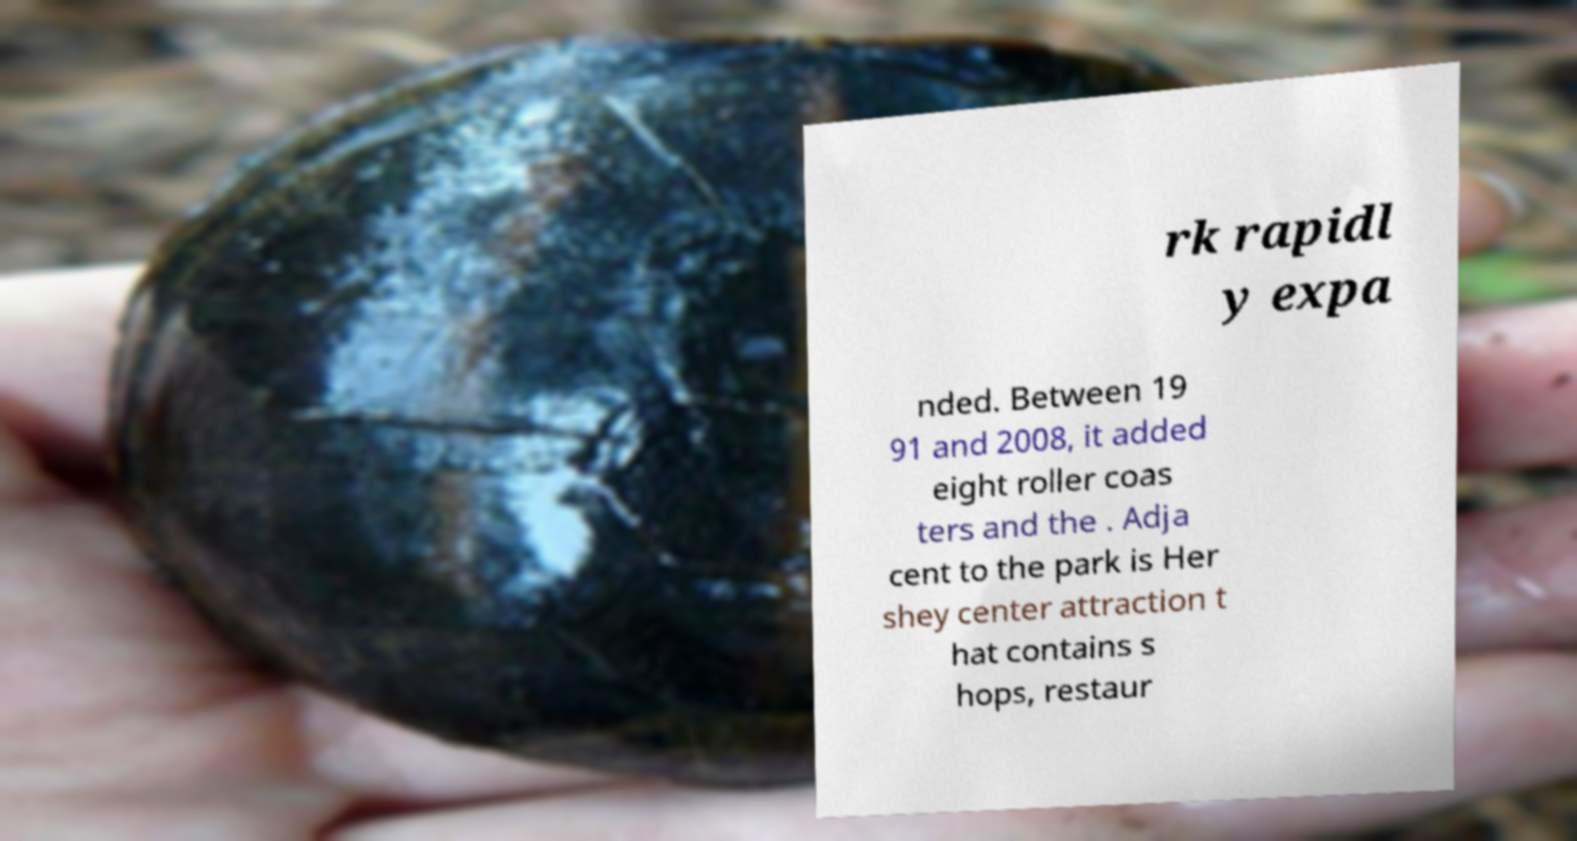Can you read and provide the text displayed in the image?This photo seems to have some interesting text. Can you extract and type it out for me? rk rapidl y expa nded. Between 19 91 and 2008, it added eight roller coas ters and the . Adja cent to the park is Her shey center attraction t hat contains s hops, restaur 